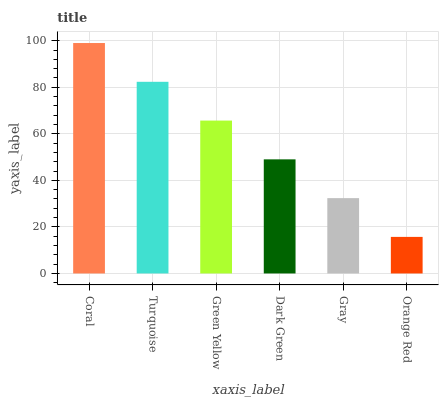Is Turquoise the minimum?
Answer yes or no. No. Is Turquoise the maximum?
Answer yes or no. No. Is Coral greater than Turquoise?
Answer yes or no. Yes. Is Turquoise less than Coral?
Answer yes or no. Yes. Is Turquoise greater than Coral?
Answer yes or no. No. Is Coral less than Turquoise?
Answer yes or no. No. Is Green Yellow the high median?
Answer yes or no. Yes. Is Dark Green the low median?
Answer yes or no. Yes. Is Coral the high median?
Answer yes or no. No. Is Gray the low median?
Answer yes or no. No. 